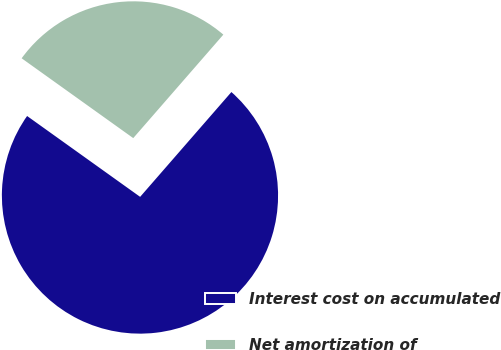Convert chart. <chart><loc_0><loc_0><loc_500><loc_500><pie_chart><fcel>Interest cost on accumulated<fcel>Net amortization of<nl><fcel>73.48%<fcel>26.52%<nl></chart> 